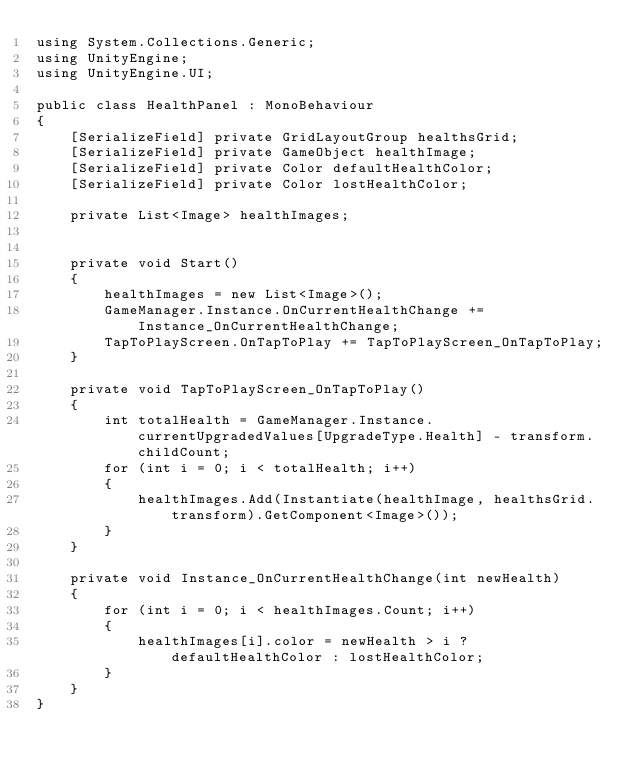Convert code to text. <code><loc_0><loc_0><loc_500><loc_500><_C#_>using System.Collections.Generic;
using UnityEngine;
using UnityEngine.UI;

public class HealthPanel : MonoBehaviour
{
    [SerializeField] private GridLayoutGroup healthsGrid;
    [SerializeField] private GameObject healthImage;
    [SerializeField] private Color defaultHealthColor;
    [SerializeField] private Color lostHealthColor;

    private List<Image> healthImages;
    

    private void Start()
    {
        healthImages = new List<Image>();
        GameManager.Instance.OnCurrentHealthChange += Instance_OnCurrentHealthChange;
        TapToPlayScreen.OnTapToPlay += TapToPlayScreen_OnTapToPlay;
    }

    private void TapToPlayScreen_OnTapToPlay()
    {
        int totalHealth = GameManager.Instance.currentUpgradedValues[UpgradeType.Health] - transform.childCount;
        for (int i = 0; i < totalHealth; i++)
        {
            healthImages.Add(Instantiate(healthImage, healthsGrid.transform).GetComponent<Image>());
        }
    }

    private void Instance_OnCurrentHealthChange(int newHealth)
    {
        for (int i = 0; i < healthImages.Count; i++)
        {
            healthImages[i].color = newHealth > i ? defaultHealthColor : lostHealthColor;
        }
    }
}
</code> 